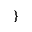Convert formula to latex. <formula><loc_0><loc_0><loc_500><loc_500>\}</formula> 